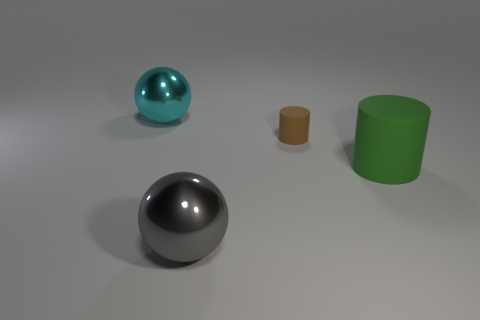Add 3 purple cylinders. How many objects exist? 7 Add 4 gray metallic things. How many gray metallic things exist? 5 Subtract 0 purple cubes. How many objects are left? 4 Subtract all tiny rubber objects. Subtract all brown rubber cylinders. How many objects are left? 2 Add 2 brown matte things. How many brown matte things are left? 3 